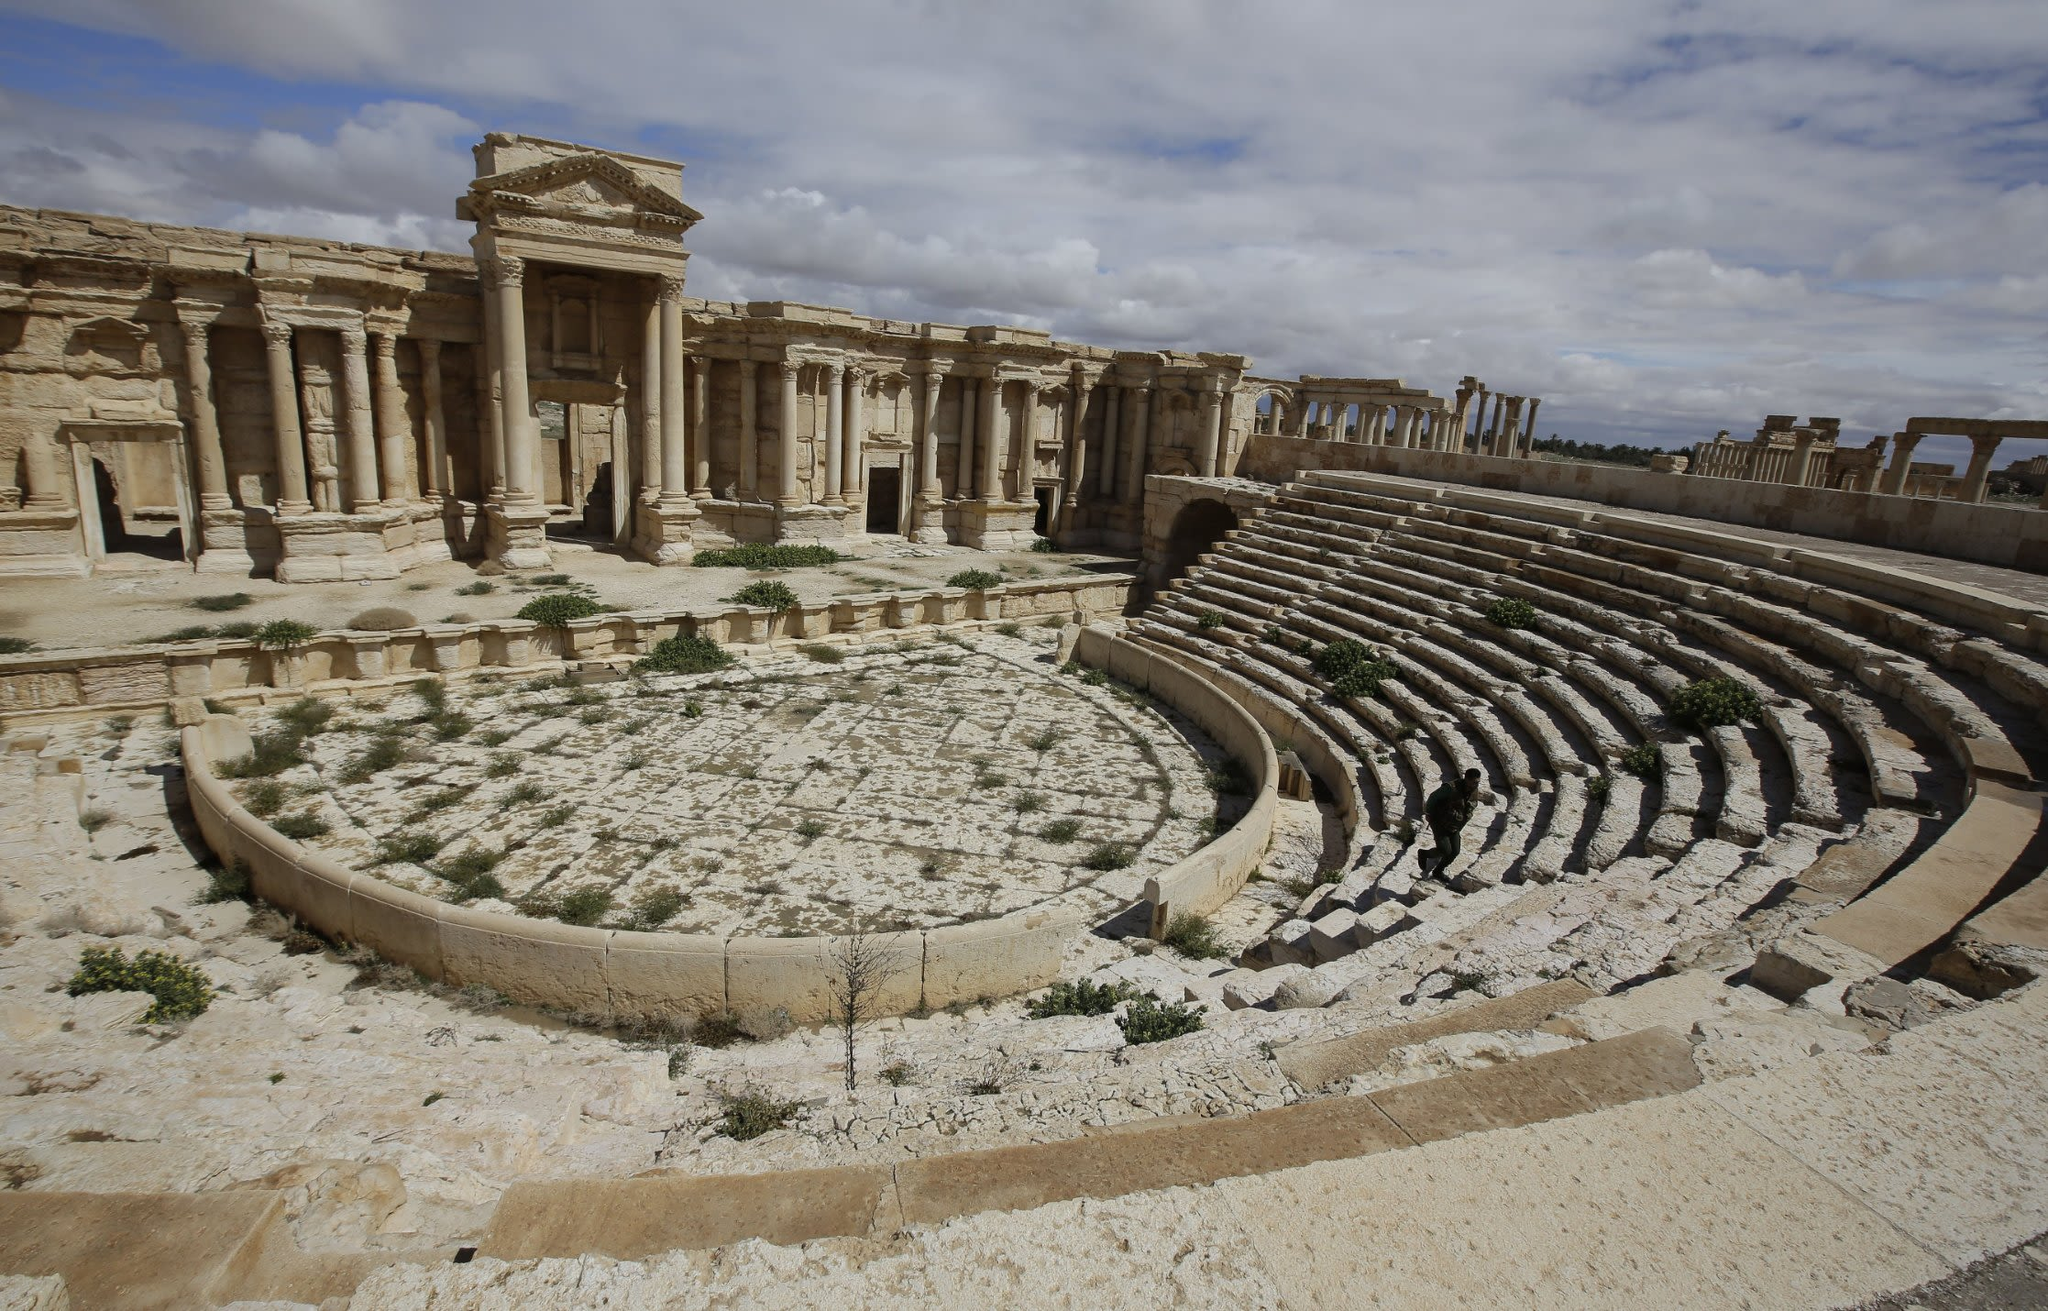What are the key elements in this picture? The image captures the haunting beauty of the ancient city of Palmyra in Syria. The most prominent feature is the remains of a grand theater, showcasing the city's rich historical significance. The semicircular seating arrangement, carved meticulously from sandstone, surrounds the central stage, which stands in various states of decay, reflecting the passage of time. The backdrop is adorned with columns and intricate architectural details, signifying the grandeur of this ancient site. Above, a cloudy gray sky casts a somber ambiance over the scene, contrasting with the predominantly beige and gray hues of the sandstone ruins. The perspective from the seating area looking towards the stage provides a sense of the scale and magnificence of this significant historical landmark. 